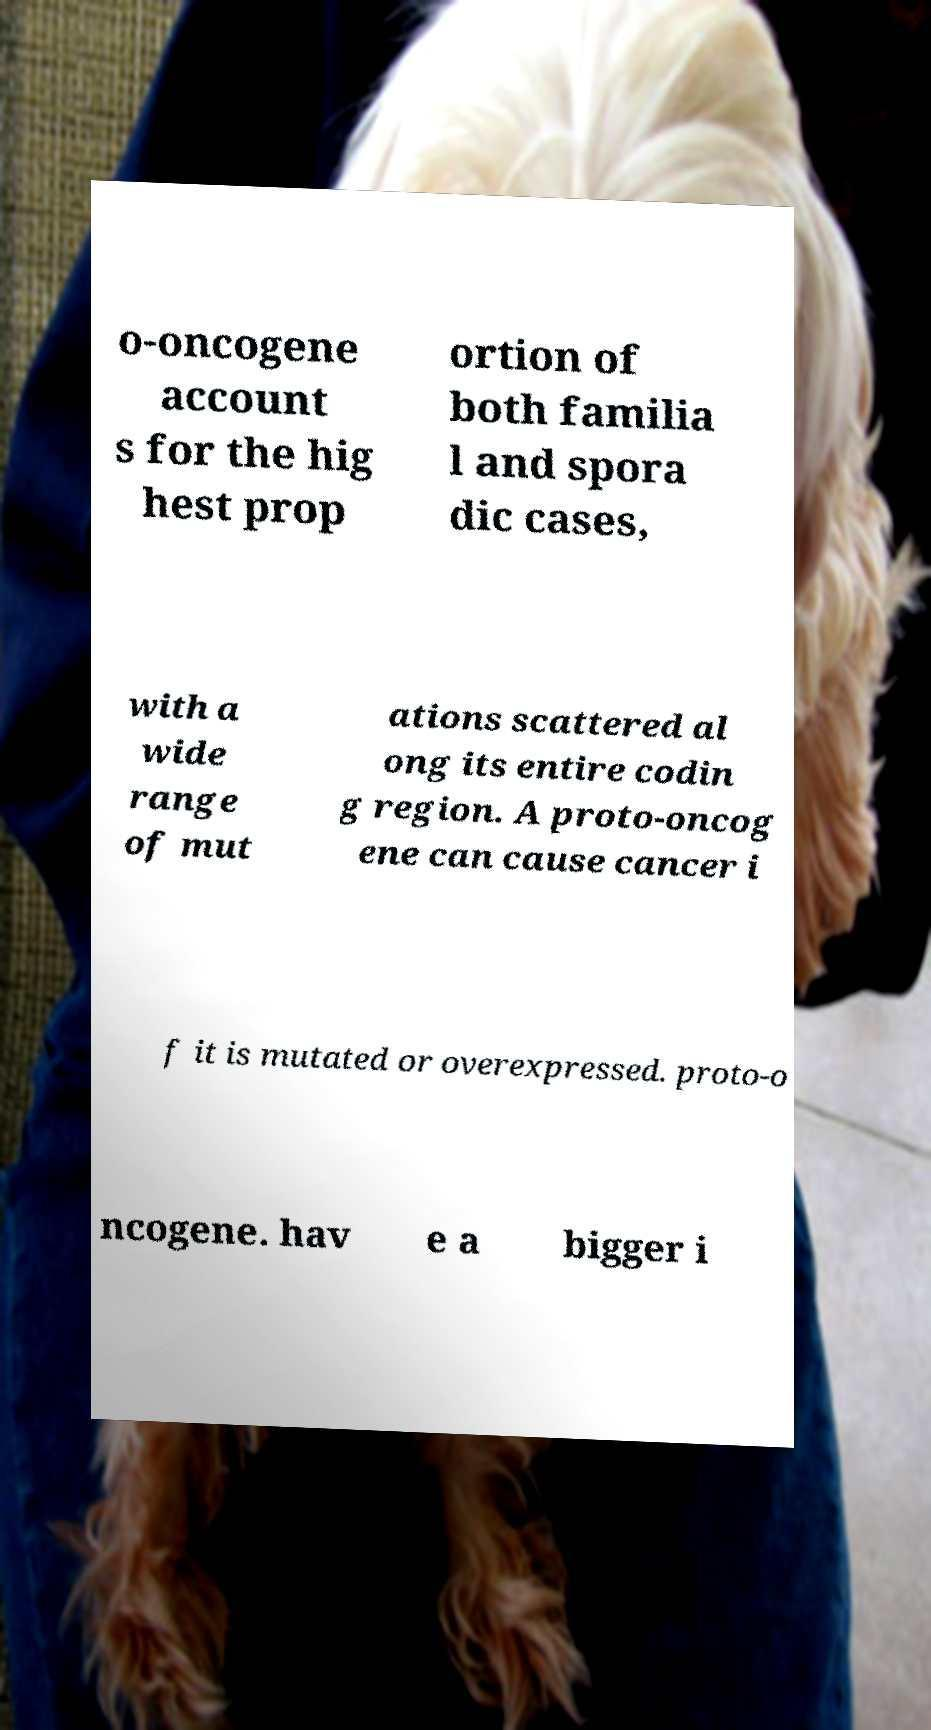What messages or text are displayed in this image? I need them in a readable, typed format. o-oncogene account s for the hig hest prop ortion of both familia l and spora dic cases, with a wide range of mut ations scattered al ong its entire codin g region. A proto-oncog ene can cause cancer i f it is mutated or overexpressed. proto-o ncogene. hav e a bigger i 